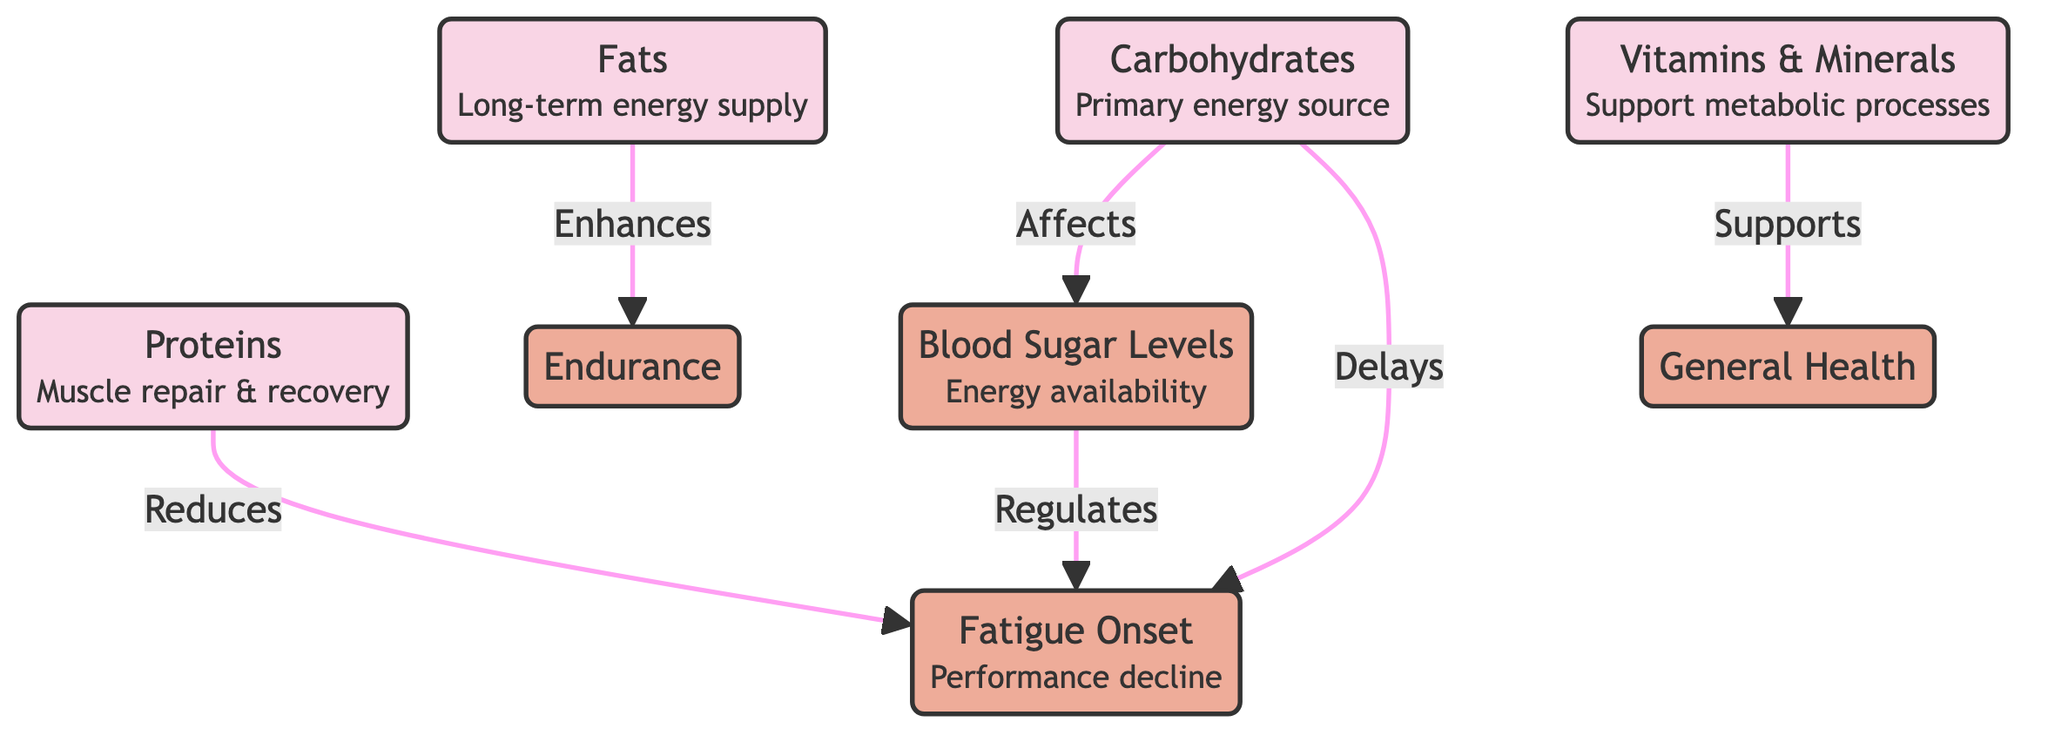What is the primary energy source for cyclists? The diagram shows a node labeled "Carbohydrates" connected to "Blood Sugar Levels." This indicates that carbohydrates are the primary energy source that affects energy availability.
Answer: Carbohydrates How many nutrient classes are represented in the diagram? The diagram contains four nutrient classes: Carbohydrates, Proteins, Fats, and Vitamins & Minerals. Counting these nodes gives us a total of four nutrient classes.
Answer: 4 What effect do proteins have on fatigue onset? The diagram states that "Proteins" reduce "Fatigue Onset." This indicates the direct relationship showing how the consumption of proteins impacts the onset of fatigue.
Answer: Reduces Which nutrient enhances endurance? The diagram indicates that "Fats" enhance "Endurance." This suggests that the intake of fats can improve a cyclist's endurance during performance.
Answer: Enhances What role do vitamins and minerals play in overall health? The diagram shows that "Vitamins & Minerals" support "General Health." This connection emphasizes the importance of these nutrients for maintaining metabolic processes and overall well-being.
Answer: Supports How do carbohydrates affect fatigue onset? In the diagram, it is shown that "Carbohydrates" both affect "Blood Sugar Levels" and delay "Fatigue Onset." This means carbohydrates play a dual role: they provide energy and help postpone fatigue in cyclists.
Answer: Delays What is the relationship between blood sugar levels and fatigue onset? The diagram illustrates that "Blood Sugar Levels" regulate "Fatigue Onset." This indicates that the level of blood sugar has a direct impact on when a cyclist might experience fatigue.
Answer: Regulates What is the effect of fats on performance? The diagram indicates that "Fats" enhance "Endurance." This highlights that fats are beneficial for improving a cyclist's performance, specifically their endurance capabilities.
Answer: Enhances 